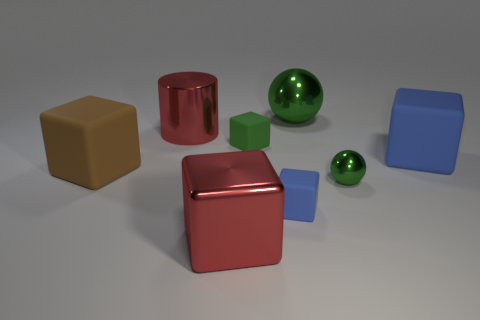Add 2 big metal cylinders. How many objects exist? 10 Subtract all large red metallic blocks. How many blocks are left? 4 Subtract all green blocks. How many blocks are left? 4 Subtract all cylinders. How many objects are left? 7 Subtract 0 cyan cubes. How many objects are left? 8 Subtract 4 blocks. How many blocks are left? 1 Subtract all brown cubes. Subtract all green cylinders. How many cubes are left? 4 Subtract all blue cylinders. How many green blocks are left? 1 Subtract all cubes. Subtract all red balls. How many objects are left? 3 Add 5 big metallic blocks. How many big metallic blocks are left? 6 